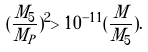Convert formula to latex. <formula><loc_0><loc_0><loc_500><loc_500>( \frac { M _ { 5 } } { M _ { P } } ) ^ { 2 } > 1 0 ^ { - 1 1 } ( \frac { M } { M _ { 5 } } ) .</formula> 